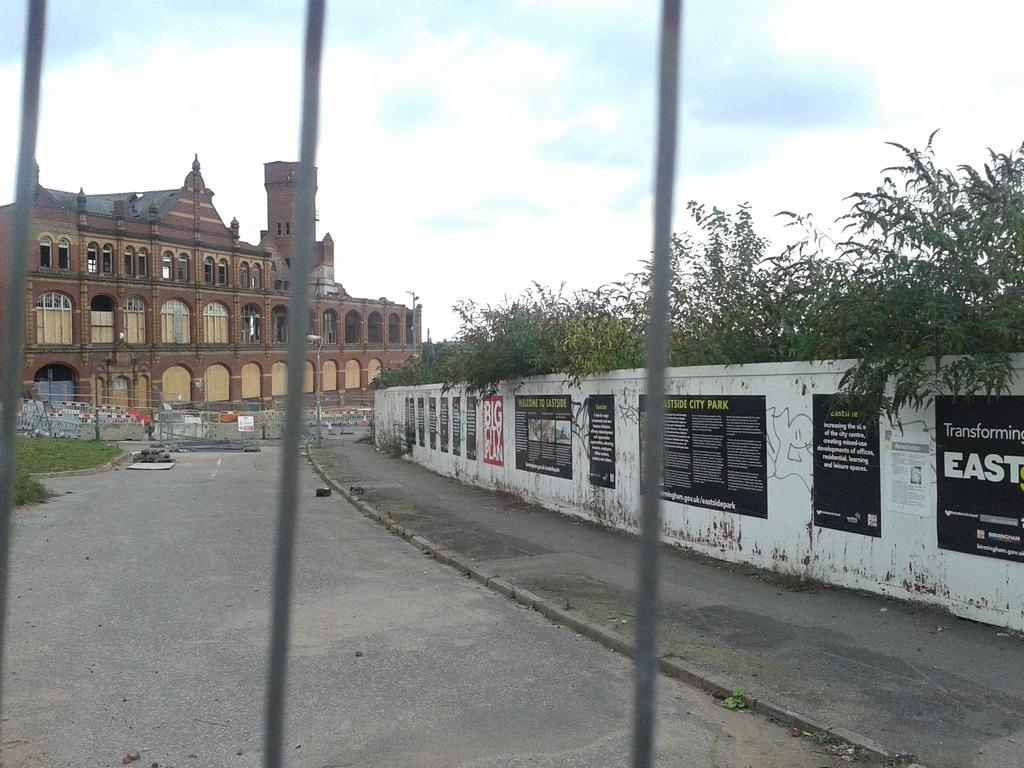What can be seen on the left side of the image? There is a road on the left side of the image. What is the most prominent feature in the image? There is a very big building in the image. What is on the right side of the image? There is a wall on the right side of the image. What type of vegetation is present in the image? There are trees in the image. How many legs does the robin have in the image? There is no robin present in the image, so it is not possible to determine the number of legs it might have. What type of stocking is hanging on the wall in the image? There is no stocking present in the image; only a road, a big building, a wall, and trees are visible. 